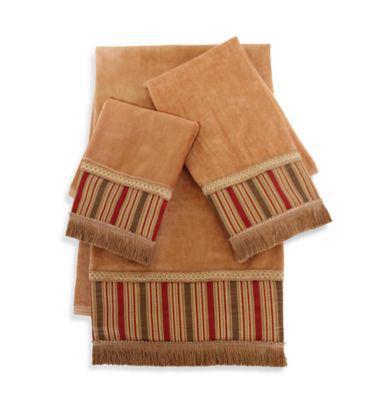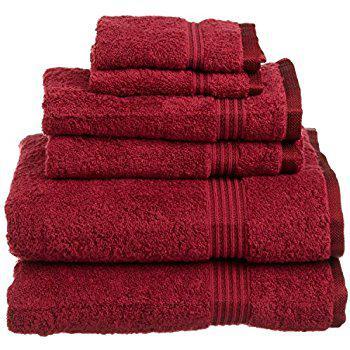The first image is the image on the left, the second image is the image on the right. Considering the images on both sides, is "Seven or fewer towels are visible." valid? Answer yes or no. No. The first image is the image on the left, the second image is the image on the right. Examine the images to the left and right. Is the description "IN at least one image there is a tower of three red towels." accurate? Answer yes or no. No. 